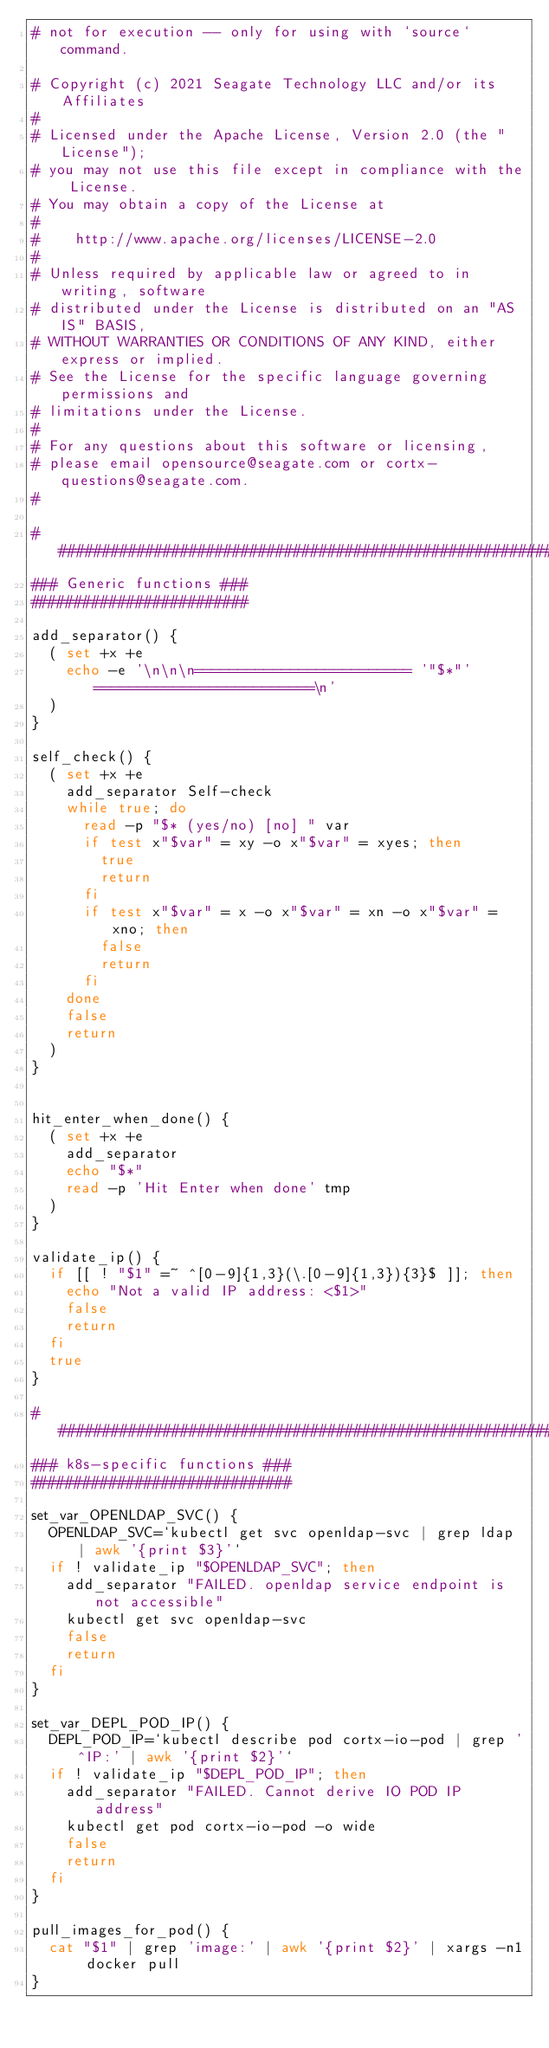Convert code to text. <code><loc_0><loc_0><loc_500><loc_500><_Bash_># not for execution -- only for using with `source` command.

# Copyright (c) 2021 Seagate Technology LLC and/or its Affiliates
#
# Licensed under the Apache License, Version 2.0 (the "License");
# you may not use this file except in compliance with the License.
# You may obtain a copy of the License at
#
#    http://www.apache.org/licenses/LICENSE-2.0
#
# Unless required by applicable law or agreed to in writing, software
# distributed under the License is distributed on an "AS IS" BASIS,
# WITHOUT WARRANTIES OR CONDITIONS OF ANY KIND, either express or implied.
# See the License for the specific language governing permissions and
# limitations under the License.
#
# For any questions about this software or licensing,
# please email opensource@seagate.com or cortx-questions@seagate.com.
#

###########################################################################
### Generic functions ###
#########################

add_separator() {
  ( set +x +e
    echo -e '\n\n\n========================= '"$*"' =========================\n'
  )
}

self_check() {
  ( set +x +e
    add_separator Self-check
    while true; do
      read -p "$* (yes/no) [no] " var
      if test x"$var" = xy -o x"$var" = xyes; then
        true
        return
      fi
      if test x"$var" = x -o x"$var" = xn -o x"$var" = xno; then
        false
        return
      fi
    done
    false
    return
  )
}


hit_enter_when_done() {
  ( set +x +e
    add_separator
    echo "$*"
    read -p 'Hit Enter when done' tmp
  )
}

validate_ip() {
  if [[ ! "$1" =~ ^[0-9]{1,3}(\.[0-9]{1,3}){3}$ ]]; then
    echo "Not a valid IP address: <$1>"
    false
    return
  fi
  true
}

###########################################################################
### k8s-specific functions ###
##############################

set_var_OPENLDAP_SVC() {
  OPENLDAP_SVC=`kubectl get svc openldap-svc | grep ldap | awk '{print $3}'`
  if ! validate_ip "$OPENLDAP_SVC"; then
    add_separator "FAILED. openldap service endpoint is not accessible"
    kubectl get svc openldap-svc
    false
    return
  fi
}

set_var_DEPL_POD_IP() {
  DEPL_POD_IP=`kubectl describe pod cortx-io-pod | grep '^IP:' | awk '{print $2}'`
  if ! validate_ip "$DEPL_POD_IP"; then
    add_separator "FAILED. Cannot derive IO POD IP address"
    kubectl get pod cortx-io-pod -o wide
    false
    return
  fi
}

pull_images_for_pod() {
  cat "$1" | grep 'image:' | awk '{print $2}' | xargs -n1 docker pull
}
</code> 